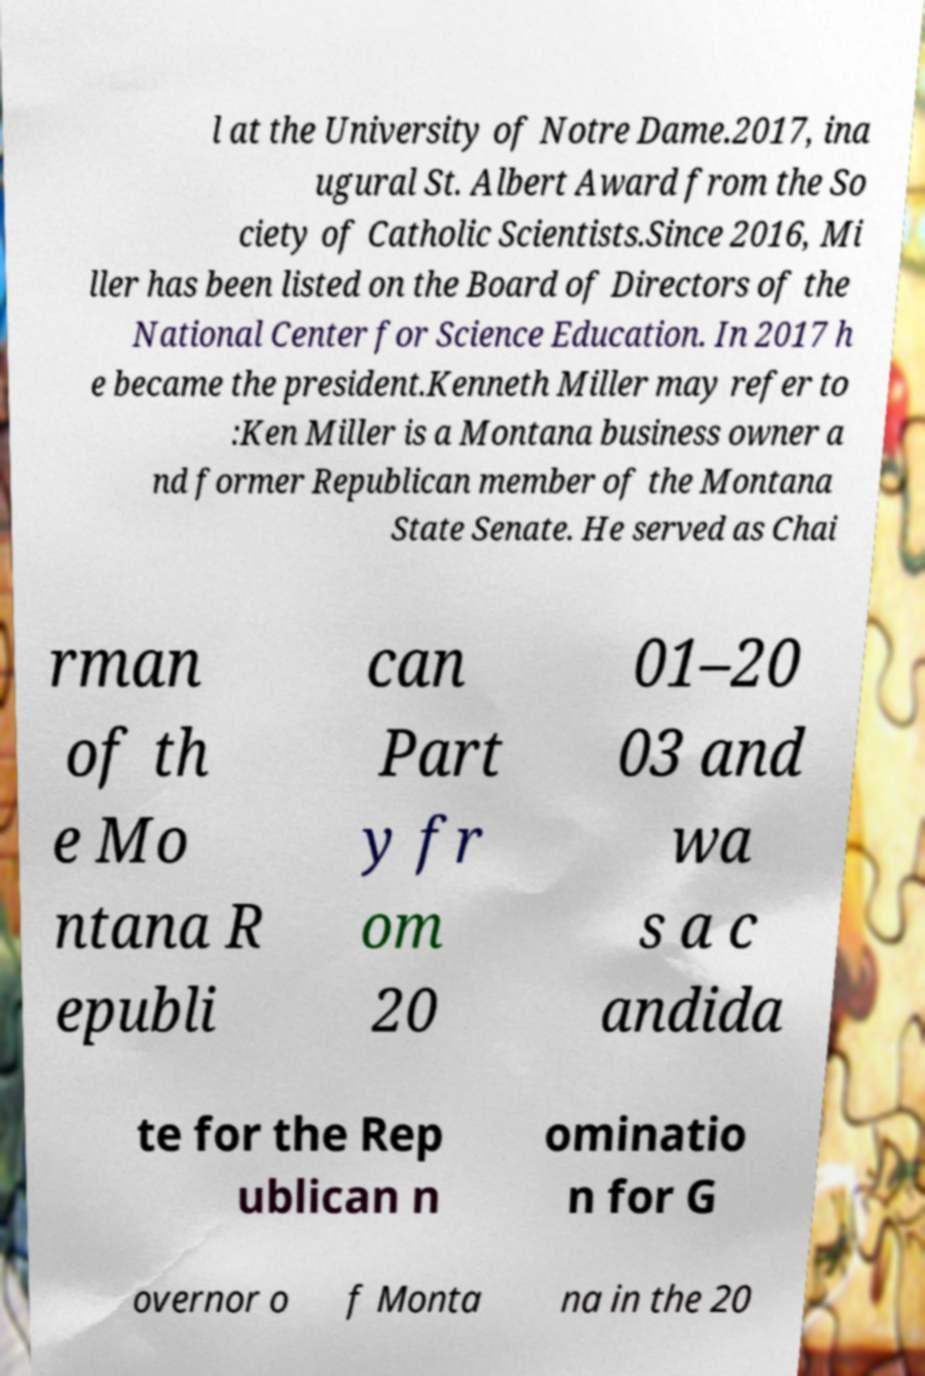I need the written content from this picture converted into text. Can you do that? l at the University of Notre Dame.2017, ina ugural St. Albert Award from the So ciety of Catholic Scientists.Since 2016, Mi ller has been listed on the Board of Directors of the National Center for Science Education. In 2017 h e became the president.Kenneth Miller may refer to :Ken Miller is a Montana business owner a nd former Republican member of the Montana State Senate. He served as Chai rman of th e Mo ntana R epubli can Part y fr om 20 01–20 03 and wa s a c andida te for the Rep ublican n ominatio n for G overnor o f Monta na in the 20 